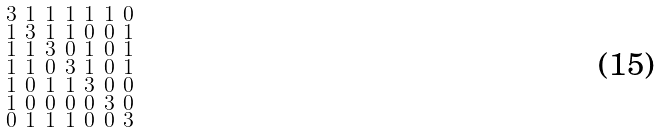<formula> <loc_0><loc_0><loc_500><loc_500>\begin{smallmatrix} 3 & 1 & 1 & 1 & 1 & 1 & 0 \\ 1 & 3 & 1 & 1 & 0 & 0 & 1 \\ 1 & 1 & 3 & 0 & 1 & 0 & 1 \\ 1 & 1 & 0 & 3 & 1 & 0 & 1 \\ 1 & 0 & 1 & 1 & 3 & 0 & 0 \\ 1 & 0 & 0 & 0 & 0 & 3 & 0 \\ 0 & 1 & 1 & 1 & 0 & 0 & 3 \end{smallmatrix}</formula> 